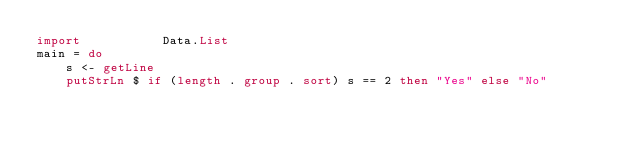<code> <loc_0><loc_0><loc_500><loc_500><_Haskell_>import           Data.List
main = do
    s <- getLine
    putStrLn $ if (length . group . sort) s == 2 then "Yes" else "No"
</code> 